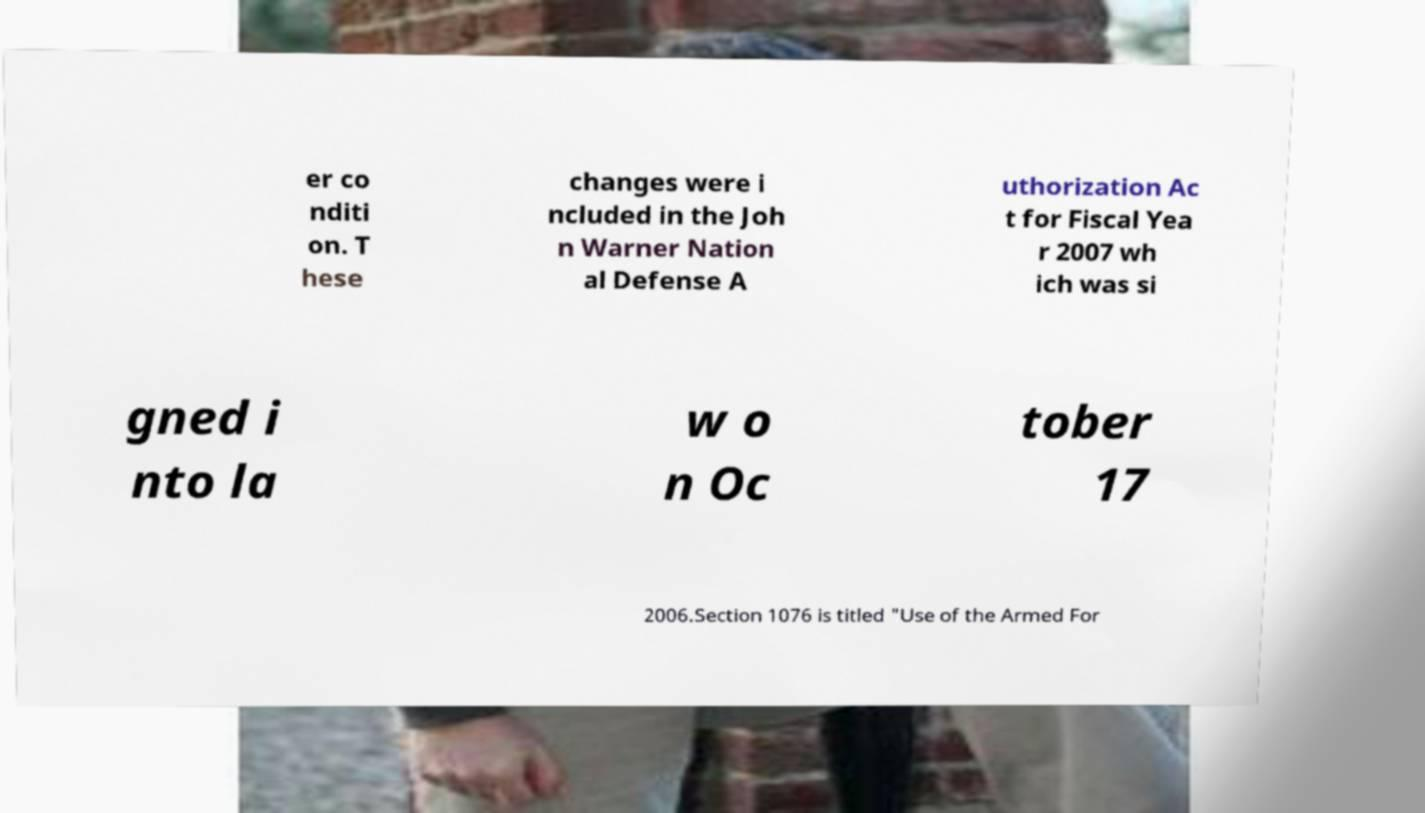Can you accurately transcribe the text from the provided image for me? er co nditi on. T hese changes were i ncluded in the Joh n Warner Nation al Defense A uthorization Ac t for Fiscal Yea r 2007 wh ich was si gned i nto la w o n Oc tober 17 2006.Section 1076 is titled "Use of the Armed For 